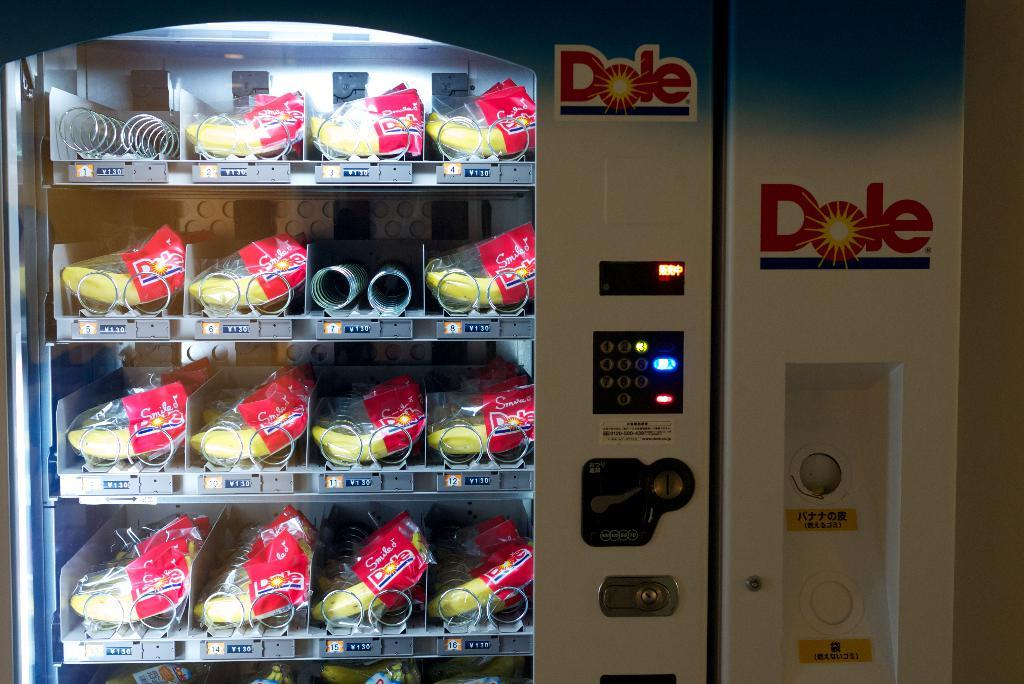<image>
Present a compact description of the photo's key features. A vending machine for snacks with a large Dole sign on it 